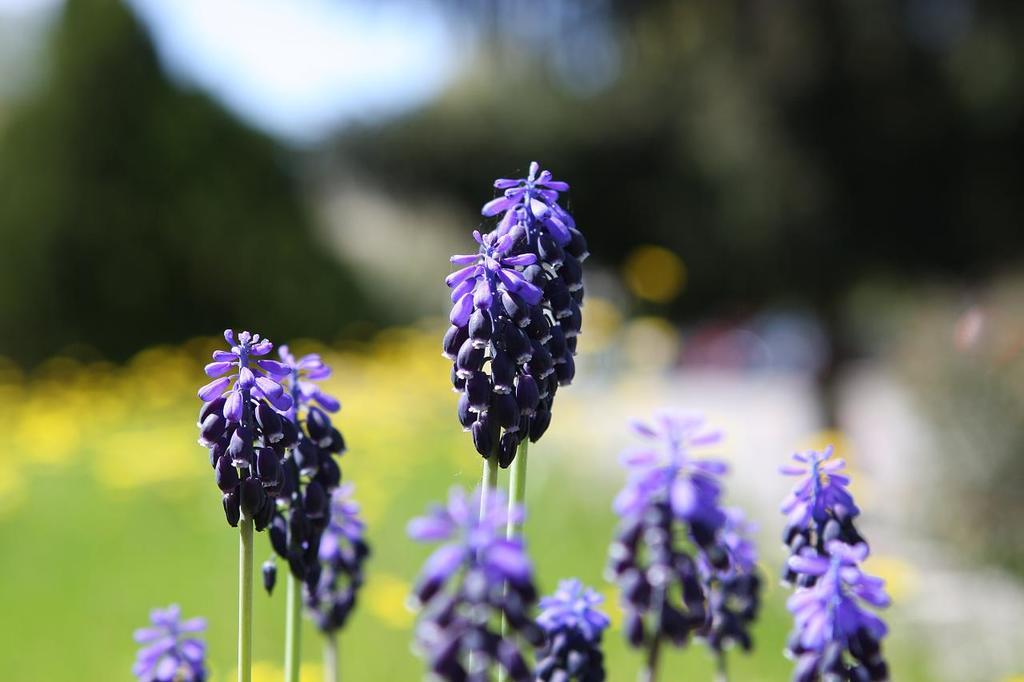What type of plants can be seen in the image? There are many flowers in the image. What color are the flowers? The flowers are purple in color. Can you describe any part of the flowers besides the petals? The stem of the flower is visible in the image. How would you describe the background of the image? The background of the image is blurred. Can you see any seashore in the image? There is no seashore present in the image; it features many purple flowers with visible stems and a blurred background. 